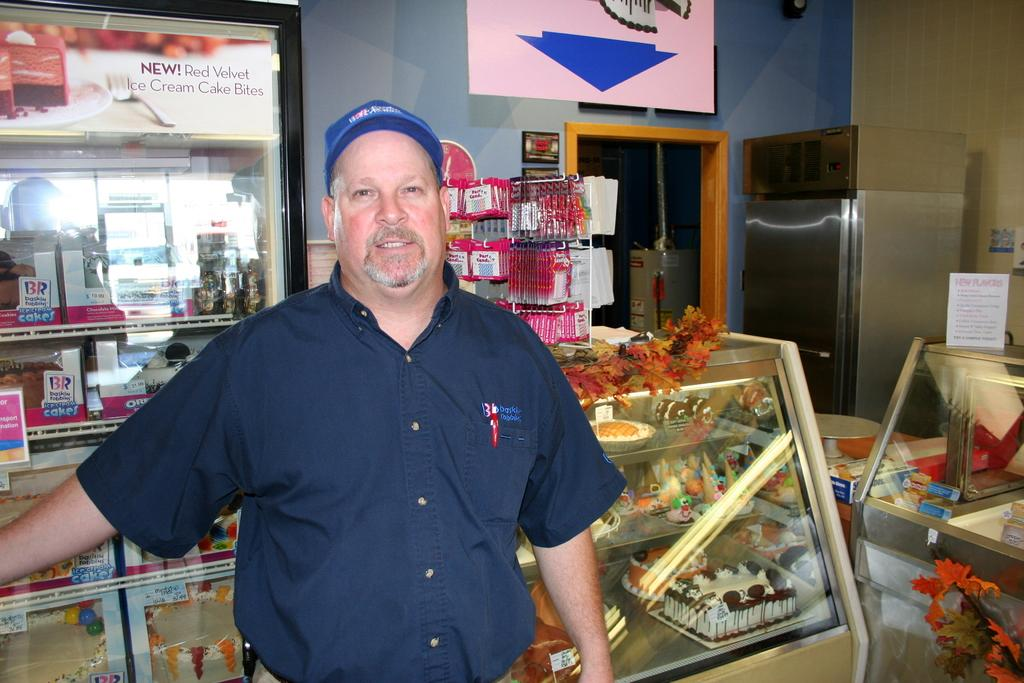What is the main subject of the image? There is a man standing in the image. What can be seen in the background of the image? In the background, there are cakes, refrigerators, a wall, and other unspecified objects. Can you describe the objects in the background? The background includes cakes, refrigerators, and a wall. There are also other unspecified objects present. What type of force is being applied to the man in the image? There is no indication of any force being applied to the man in the image; he is simply standing. Is there any evidence of slavery in the image? There is no indication of slavery or any related activities in the image. 